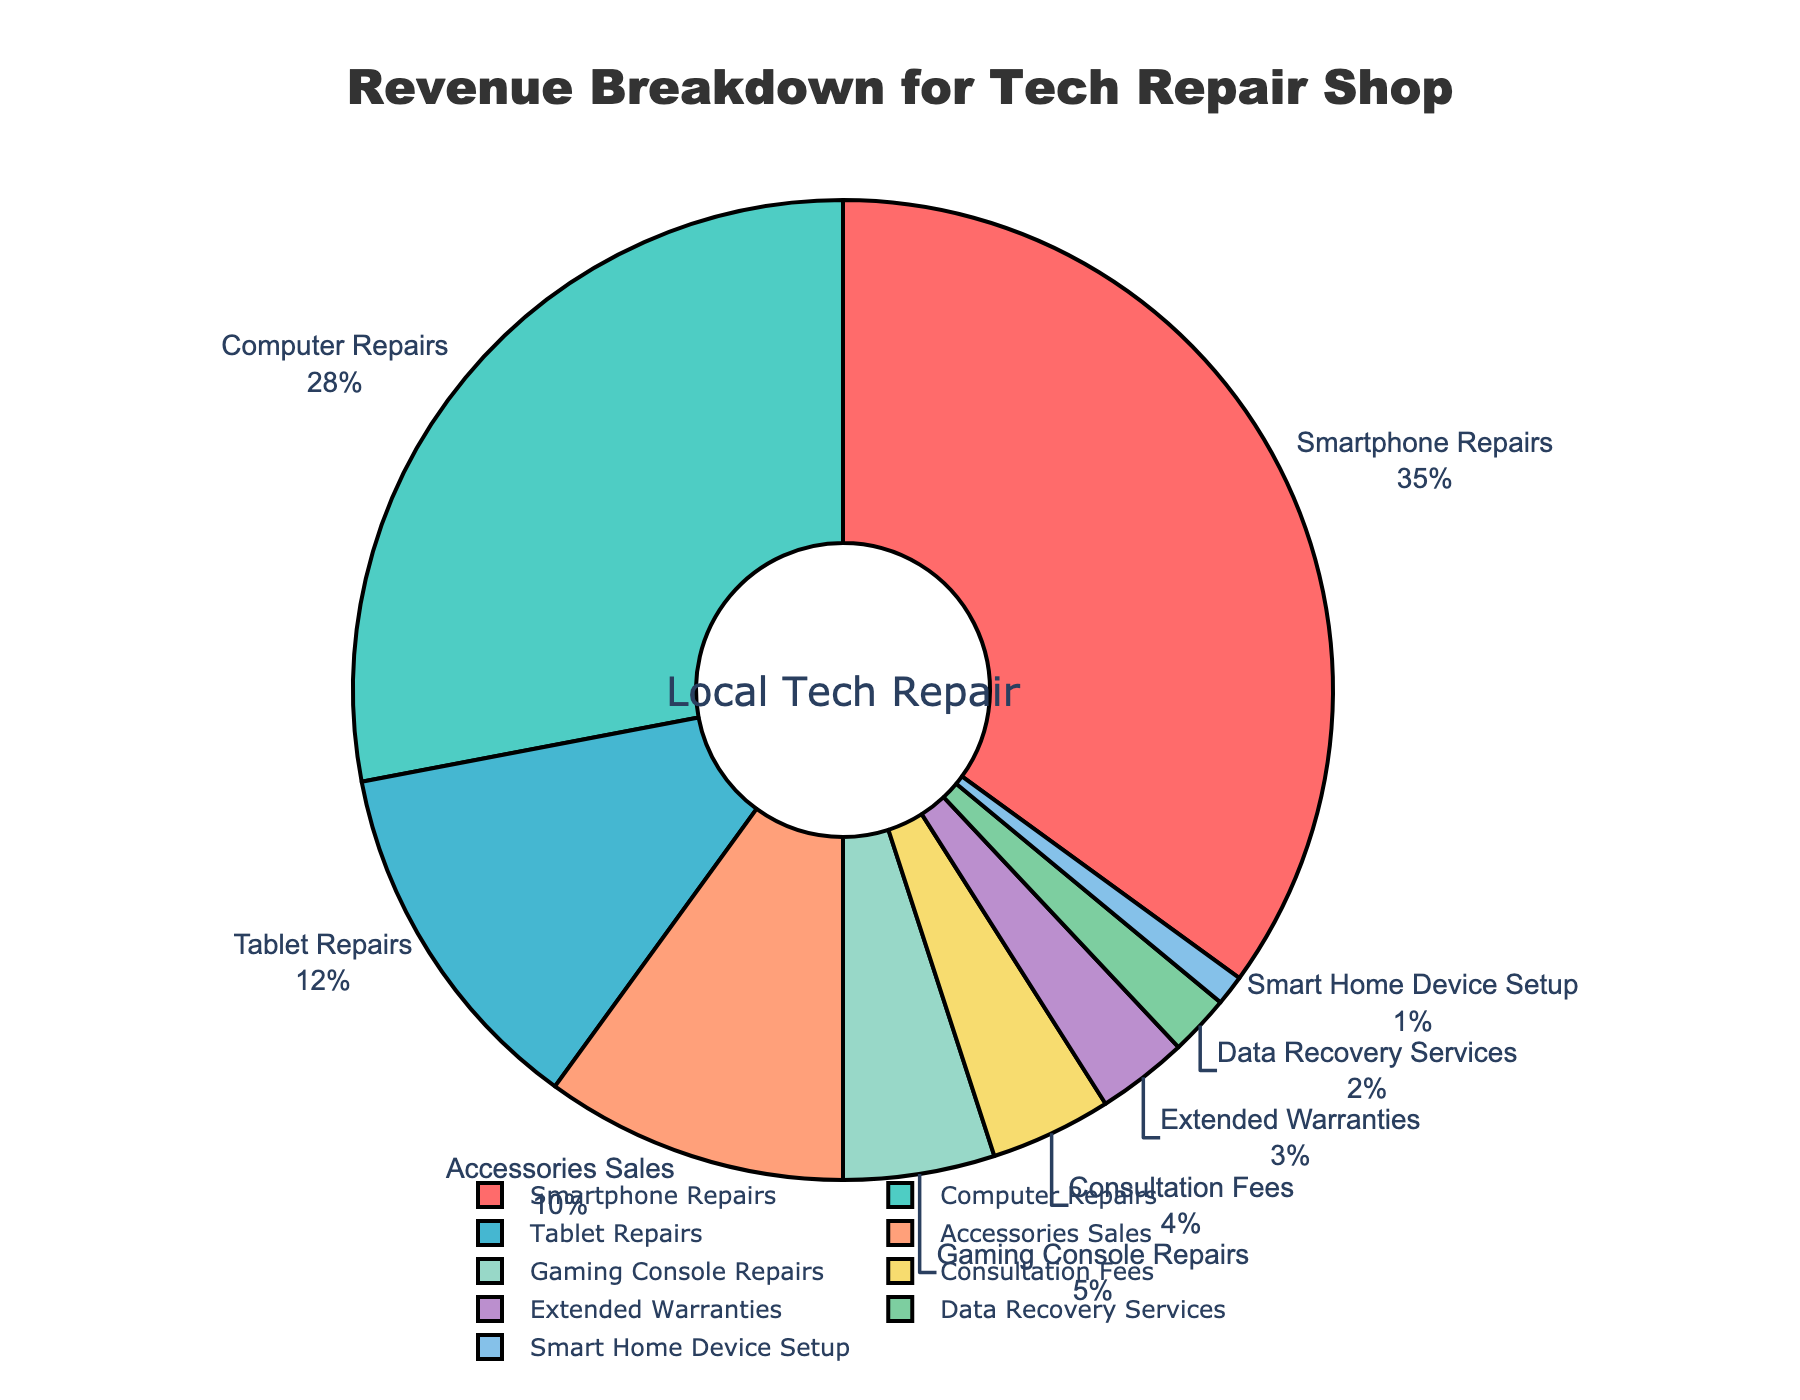What is the largest revenue source for the tech repair shop? The largest section in the pie chart is labeled "Smartphone Repairs," which makes up the largest portion of the pie.
Answer: Smartphone Repairs How much of the total revenue is made up by Computer Repairs and Tablet Repairs combined? The percentages for Computer Repairs and Tablet Repairs are 28% and 12%, respectively. Adding those together gives 28 + 12 = 40%.
Answer: 40% Are there more revenues generated from repairs or consultations? Summing up the percentages for the various types of repairs (Smartphone 35%, Computer 28%, Tablet 12%, and Gaming Console 5%) gives a total of 35 + 28 + 12 + 5 = 80%. The Consultation Fees segment alone is 4%. Hence, repairs constitute a larger share.
Answer: Repairs Which revenue source contributes the least to the total revenue? The smallest segment in the pie chart is labeled "Smart Home Device Setup," which occupies the smallest area.
Answer: Smart Home Device Setup How does the revenue from Accessories Sales compare to Data Recovery Services? The pie chart shows Accessories Sales at 10% and Data Recovery Services at 2%. Since 10% is greater than 2%, Accessories Sales generate more revenue.
Answer: Accessories Sales generates more revenue What is the difference in revenue between the largest and smallest revenue sources? The largest source, Smartphone Repairs, is 35%, and the smallest source, Smart Home Device Setup, is 1%. The difference is 35% - 1% = 34%.
Answer: 34% If we combine the percentages of Extended Warranties and Consultation Fees, does it surpass Accessories Sales? Extended Warranties contribute 3% and Consultation Fees contribute 4%. Combined, they make 3 + 4 = 7%, which is less than Accessories Sales at 10%.
Answer: No Which two revenue sources combined would make up exactly half of the total revenue? Smartphone Repairs is 35% and Computer Repairs is 28%; adding these gives 35 + 28 = 63%. None of the combinations of two revenue sources sum up exactly to 50%, but Smartphone Repairs and Tablet Repairs come closest at 35 + 12 = 47%.
Answer: None Are Extended Warranties contributing more or less than Consultation Fees? The pie chart shows Extended Warranties at 3% and Consultation Fees at 4%. Since 3% is less than 4%, Extended Warranties contribute less.
Answer: Extended Warranties contribute less 